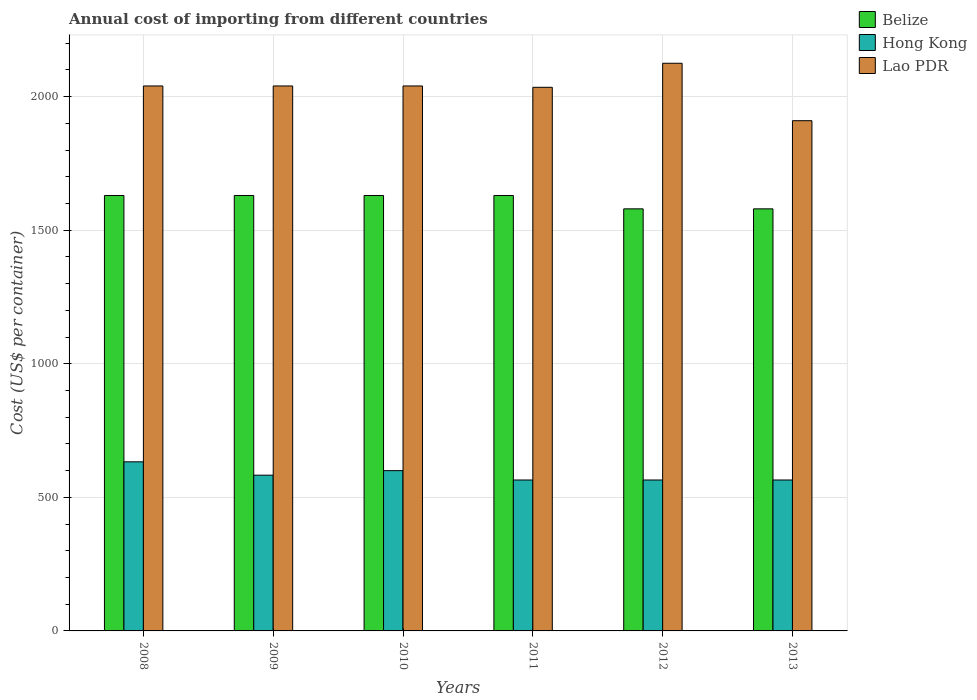How many groups of bars are there?
Offer a terse response. 6. How many bars are there on the 5th tick from the left?
Offer a very short reply. 3. In how many cases, is the number of bars for a given year not equal to the number of legend labels?
Provide a short and direct response. 0. What is the total annual cost of importing in Lao PDR in 2009?
Your answer should be compact. 2040. Across all years, what is the maximum total annual cost of importing in Hong Kong?
Provide a short and direct response. 633. Across all years, what is the minimum total annual cost of importing in Hong Kong?
Offer a very short reply. 565. What is the total total annual cost of importing in Hong Kong in the graph?
Your response must be concise. 3511. What is the difference between the total annual cost of importing in Belize in 2011 and that in 2013?
Keep it short and to the point. 50. What is the difference between the total annual cost of importing in Lao PDR in 2008 and the total annual cost of importing in Belize in 2013?
Offer a very short reply. 460. What is the average total annual cost of importing in Belize per year?
Give a very brief answer. 1613.33. In the year 2008, what is the difference between the total annual cost of importing in Belize and total annual cost of importing in Lao PDR?
Give a very brief answer. -410. What is the ratio of the total annual cost of importing in Lao PDR in 2009 to that in 2013?
Provide a short and direct response. 1.07. Is the total annual cost of importing in Hong Kong in 2009 less than that in 2012?
Keep it short and to the point. No. What is the difference between the highest and the lowest total annual cost of importing in Belize?
Make the answer very short. 50. What does the 1st bar from the left in 2009 represents?
Offer a terse response. Belize. What does the 1st bar from the right in 2012 represents?
Offer a terse response. Lao PDR. How many bars are there?
Your response must be concise. 18. Are all the bars in the graph horizontal?
Your response must be concise. No. How many years are there in the graph?
Offer a very short reply. 6. What is the difference between two consecutive major ticks on the Y-axis?
Your answer should be compact. 500. Does the graph contain any zero values?
Give a very brief answer. No. Where does the legend appear in the graph?
Provide a succinct answer. Top right. How many legend labels are there?
Offer a terse response. 3. What is the title of the graph?
Your answer should be very brief. Annual cost of importing from different countries. Does "El Salvador" appear as one of the legend labels in the graph?
Your answer should be compact. No. What is the label or title of the X-axis?
Provide a short and direct response. Years. What is the label or title of the Y-axis?
Provide a succinct answer. Cost (US$ per container). What is the Cost (US$ per container) in Belize in 2008?
Offer a very short reply. 1630. What is the Cost (US$ per container) in Hong Kong in 2008?
Give a very brief answer. 633. What is the Cost (US$ per container) in Lao PDR in 2008?
Your answer should be very brief. 2040. What is the Cost (US$ per container) in Belize in 2009?
Make the answer very short. 1630. What is the Cost (US$ per container) in Hong Kong in 2009?
Provide a short and direct response. 583. What is the Cost (US$ per container) in Lao PDR in 2009?
Offer a very short reply. 2040. What is the Cost (US$ per container) of Belize in 2010?
Offer a very short reply. 1630. What is the Cost (US$ per container) of Hong Kong in 2010?
Offer a very short reply. 600. What is the Cost (US$ per container) in Lao PDR in 2010?
Your response must be concise. 2040. What is the Cost (US$ per container) of Belize in 2011?
Your response must be concise. 1630. What is the Cost (US$ per container) of Hong Kong in 2011?
Provide a short and direct response. 565. What is the Cost (US$ per container) of Lao PDR in 2011?
Your answer should be compact. 2035. What is the Cost (US$ per container) of Belize in 2012?
Ensure brevity in your answer.  1580. What is the Cost (US$ per container) in Hong Kong in 2012?
Provide a succinct answer. 565. What is the Cost (US$ per container) of Lao PDR in 2012?
Your answer should be very brief. 2125. What is the Cost (US$ per container) of Belize in 2013?
Offer a terse response. 1580. What is the Cost (US$ per container) in Hong Kong in 2013?
Offer a terse response. 565. What is the Cost (US$ per container) in Lao PDR in 2013?
Keep it short and to the point. 1910. Across all years, what is the maximum Cost (US$ per container) in Belize?
Your answer should be compact. 1630. Across all years, what is the maximum Cost (US$ per container) of Hong Kong?
Your response must be concise. 633. Across all years, what is the maximum Cost (US$ per container) of Lao PDR?
Provide a short and direct response. 2125. Across all years, what is the minimum Cost (US$ per container) of Belize?
Offer a terse response. 1580. Across all years, what is the minimum Cost (US$ per container) in Hong Kong?
Your answer should be compact. 565. Across all years, what is the minimum Cost (US$ per container) of Lao PDR?
Offer a terse response. 1910. What is the total Cost (US$ per container) of Belize in the graph?
Give a very brief answer. 9680. What is the total Cost (US$ per container) of Hong Kong in the graph?
Offer a very short reply. 3511. What is the total Cost (US$ per container) in Lao PDR in the graph?
Offer a very short reply. 1.22e+04. What is the difference between the Cost (US$ per container) in Hong Kong in 2008 and that in 2009?
Offer a very short reply. 50. What is the difference between the Cost (US$ per container) of Lao PDR in 2008 and that in 2009?
Make the answer very short. 0. What is the difference between the Cost (US$ per container) of Belize in 2008 and that in 2010?
Your answer should be compact. 0. What is the difference between the Cost (US$ per container) in Hong Kong in 2008 and that in 2010?
Your answer should be compact. 33. What is the difference between the Cost (US$ per container) of Lao PDR in 2008 and that in 2010?
Make the answer very short. 0. What is the difference between the Cost (US$ per container) in Belize in 2008 and that in 2011?
Ensure brevity in your answer.  0. What is the difference between the Cost (US$ per container) in Hong Kong in 2008 and that in 2011?
Provide a short and direct response. 68. What is the difference between the Cost (US$ per container) of Lao PDR in 2008 and that in 2011?
Make the answer very short. 5. What is the difference between the Cost (US$ per container) in Hong Kong in 2008 and that in 2012?
Provide a succinct answer. 68. What is the difference between the Cost (US$ per container) in Lao PDR in 2008 and that in 2012?
Offer a very short reply. -85. What is the difference between the Cost (US$ per container) in Belize in 2008 and that in 2013?
Your response must be concise. 50. What is the difference between the Cost (US$ per container) in Hong Kong in 2008 and that in 2013?
Your answer should be very brief. 68. What is the difference between the Cost (US$ per container) of Lao PDR in 2008 and that in 2013?
Your answer should be very brief. 130. What is the difference between the Cost (US$ per container) of Belize in 2009 and that in 2010?
Offer a very short reply. 0. What is the difference between the Cost (US$ per container) of Lao PDR in 2009 and that in 2010?
Make the answer very short. 0. What is the difference between the Cost (US$ per container) in Belize in 2009 and that in 2012?
Keep it short and to the point. 50. What is the difference between the Cost (US$ per container) in Hong Kong in 2009 and that in 2012?
Offer a terse response. 18. What is the difference between the Cost (US$ per container) in Lao PDR in 2009 and that in 2012?
Offer a very short reply. -85. What is the difference between the Cost (US$ per container) of Hong Kong in 2009 and that in 2013?
Your answer should be compact. 18. What is the difference between the Cost (US$ per container) of Lao PDR in 2009 and that in 2013?
Your response must be concise. 130. What is the difference between the Cost (US$ per container) in Lao PDR in 2010 and that in 2011?
Your response must be concise. 5. What is the difference between the Cost (US$ per container) in Hong Kong in 2010 and that in 2012?
Ensure brevity in your answer.  35. What is the difference between the Cost (US$ per container) in Lao PDR in 2010 and that in 2012?
Make the answer very short. -85. What is the difference between the Cost (US$ per container) of Belize in 2010 and that in 2013?
Make the answer very short. 50. What is the difference between the Cost (US$ per container) of Hong Kong in 2010 and that in 2013?
Make the answer very short. 35. What is the difference between the Cost (US$ per container) of Lao PDR in 2010 and that in 2013?
Your response must be concise. 130. What is the difference between the Cost (US$ per container) of Lao PDR in 2011 and that in 2012?
Offer a terse response. -90. What is the difference between the Cost (US$ per container) in Belize in 2011 and that in 2013?
Your response must be concise. 50. What is the difference between the Cost (US$ per container) of Lao PDR in 2011 and that in 2013?
Keep it short and to the point. 125. What is the difference between the Cost (US$ per container) of Belize in 2012 and that in 2013?
Provide a short and direct response. 0. What is the difference between the Cost (US$ per container) of Lao PDR in 2012 and that in 2013?
Your response must be concise. 215. What is the difference between the Cost (US$ per container) in Belize in 2008 and the Cost (US$ per container) in Hong Kong in 2009?
Make the answer very short. 1047. What is the difference between the Cost (US$ per container) of Belize in 2008 and the Cost (US$ per container) of Lao PDR in 2009?
Give a very brief answer. -410. What is the difference between the Cost (US$ per container) of Hong Kong in 2008 and the Cost (US$ per container) of Lao PDR in 2009?
Make the answer very short. -1407. What is the difference between the Cost (US$ per container) of Belize in 2008 and the Cost (US$ per container) of Hong Kong in 2010?
Your response must be concise. 1030. What is the difference between the Cost (US$ per container) in Belize in 2008 and the Cost (US$ per container) in Lao PDR in 2010?
Keep it short and to the point. -410. What is the difference between the Cost (US$ per container) in Hong Kong in 2008 and the Cost (US$ per container) in Lao PDR in 2010?
Give a very brief answer. -1407. What is the difference between the Cost (US$ per container) of Belize in 2008 and the Cost (US$ per container) of Hong Kong in 2011?
Offer a very short reply. 1065. What is the difference between the Cost (US$ per container) in Belize in 2008 and the Cost (US$ per container) in Lao PDR in 2011?
Keep it short and to the point. -405. What is the difference between the Cost (US$ per container) of Hong Kong in 2008 and the Cost (US$ per container) of Lao PDR in 2011?
Provide a succinct answer. -1402. What is the difference between the Cost (US$ per container) in Belize in 2008 and the Cost (US$ per container) in Hong Kong in 2012?
Offer a very short reply. 1065. What is the difference between the Cost (US$ per container) in Belize in 2008 and the Cost (US$ per container) in Lao PDR in 2012?
Your answer should be compact. -495. What is the difference between the Cost (US$ per container) in Hong Kong in 2008 and the Cost (US$ per container) in Lao PDR in 2012?
Keep it short and to the point. -1492. What is the difference between the Cost (US$ per container) of Belize in 2008 and the Cost (US$ per container) of Hong Kong in 2013?
Your answer should be compact. 1065. What is the difference between the Cost (US$ per container) of Belize in 2008 and the Cost (US$ per container) of Lao PDR in 2013?
Your answer should be compact. -280. What is the difference between the Cost (US$ per container) in Hong Kong in 2008 and the Cost (US$ per container) in Lao PDR in 2013?
Give a very brief answer. -1277. What is the difference between the Cost (US$ per container) of Belize in 2009 and the Cost (US$ per container) of Hong Kong in 2010?
Your response must be concise. 1030. What is the difference between the Cost (US$ per container) of Belize in 2009 and the Cost (US$ per container) of Lao PDR in 2010?
Provide a succinct answer. -410. What is the difference between the Cost (US$ per container) of Hong Kong in 2009 and the Cost (US$ per container) of Lao PDR in 2010?
Offer a very short reply. -1457. What is the difference between the Cost (US$ per container) in Belize in 2009 and the Cost (US$ per container) in Hong Kong in 2011?
Your answer should be very brief. 1065. What is the difference between the Cost (US$ per container) in Belize in 2009 and the Cost (US$ per container) in Lao PDR in 2011?
Offer a very short reply. -405. What is the difference between the Cost (US$ per container) in Hong Kong in 2009 and the Cost (US$ per container) in Lao PDR in 2011?
Give a very brief answer. -1452. What is the difference between the Cost (US$ per container) in Belize in 2009 and the Cost (US$ per container) in Hong Kong in 2012?
Offer a very short reply. 1065. What is the difference between the Cost (US$ per container) of Belize in 2009 and the Cost (US$ per container) of Lao PDR in 2012?
Provide a succinct answer. -495. What is the difference between the Cost (US$ per container) of Hong Kong in 2009 and the Cost (US$ per container) of Lao PDR in 2012?
Your response must be concise. -1542. What is the difference between the Cost (US$ per container) in Belize in 2009 and the Cost (US$ per container) in Hong Kong in 2013?
Your answer should be very brief. 1065. What is the difference between the Cost (US$ per container) of Belize in 2009 and the Cost (US$ per container) of Lao PDR in 2013?
Give a very brief answer. -280. What is the difference between the Cost (US$ per container) of Hong Kong in 2009 and the Cost (US$ per container) of Lao PDR in 2013?
Your answer should be very brief. -1327. What is the difference between the Cost (US$ per container) in Belize in 2010 and the Cost (US$ per container) in Hong Kong in 2011?
Your answer should be very brief. 1065. What is the difference between the Cost (US$ per container) in Belize in 2010 and the Cost (US$ per container) in Lao PDR in 2011?
Give a very brief answer. -405. What is the difference between the Cost (US$ per container) of Hong Kong in 2010 and the Cost (US$ per container) of Lao PDR in 2011?
Your response must be concise. -1435. What is the difference between the Cost (US$ per container) of Belize in 2010 and the Cost (US$ per container) of Hong Kong in 2012?
Offer a very short reply. 1065. What is the difference between the Cost (US$ per container) of Belize in 2010 and the Cost (US$ per container) of Lao PDR in 2012?
Offer a terse response. -495. What is the difference between the Cost (US$ per container) in Hong Kong in 2010 and the Cost (US$ per container) in Lao PDR in 2012?
Give a very brief answer. -1525. What is the difference between the Cost (US$ per container) of Belize in 2010 and the Cost (US$ per container) of Hong Kong in 2013?
Give a very brief answer. 1065. What is the difference between the Cost (US$ per container) in Belize in 2010 and the Cost (US$ per container) in Lao PDR in 2013?
Ensure brevity in your answer.  -280. What is the difference between the Cost (US$ per container) in Hong Kong in 2010 and the Cost (US$ per container) in Lao PDR in 2013?
Provide a short and direct response. -1310. What is the difference between the Cost (US$ per container) in Belize in 2011 and the Cost (US$ per container) in Hong Kong in 2012?
Ensure brevity in your answer.  1065. What is the difference between the Cost (US$ per container) of Belize in 2011 and the Cost (US$ per container) of Lao PDR in 2012?
Give a very brief answer. -495. What is the difference between the Cost (US$ per container) of Hong Kong in 2011 and the Cost (US$ per container) of Lao PDR in 2012?
Provide a short and direct response. -1560. What is the difference between the Cost (US$ per container) in Belize in 2011 and the Cost (US$ per container) in Hong Kong in 2013?
Offer a very short reply. 1065. What is the difference between the Cost (US$ per container) of Belize in 2011 and the Cost (US$ per container) of Lao PDR in 2013?
Offer a terse response. -280. What is the difference between the Cost (US$ per container) in Hong Kong in 2011 and the Cost (US$ per container) in Lao PDR in 2013?
Your response must be concise. -1345. What is the difference between the Cost (US$ per container) of Belize in 2012 and the Cost (US$ per container) of Hong Kong in 2013?
Give a very brief answer. 1015. What is the difference between the Cost (US$ per container) of Belize in 2012 and the Cost (US$ per container) of Lao PDR in 2013?
Provide a short and direct response. -330. What is the difference between the Cost (US$ per container) in Hong Kong in 2012 and the Cost (US$ per container) in Lao PDR in 2013?
Your response must be concise. -1345. What is the average Cost (US$ per container) of Belize per year?
Your answer should be very brief. 1613.33. What is the average Cost (US$ per container) in Hong Kong per year?
Offer a very short reply. 585.17. What is the average Cost (US$ per container) of Lao PDR per year?
Offer a very short reply. 2031.67. In the year 2008, what is the difference between the Cost (US$ per container) in Belize and Cost (US$ per container) in Hong Kong?
Offer a terse response. 997. In the year 2008, what is the difference between the Cost (US$ per container) of Belize and Cost (US$ per container) of Lao PDR?
Your response must be concise. -410. In the year 2008, what is the difference between the Cost (US$ per container) of Hong Kong and Cost (US$ per container) of Lao PDR?
Provide a short and direct response. -1407. In the year 2009, what is the difference between the Cost (US$ per container) in Belize and Cost (US$ per container) in Hong Kong?
Your response must be concise. 1047. In the year 2009, what is the difference between the Cost (US$ per container) of Belize and Cost (US$ per container) of Lao PDR?
Your answer should be compact. -410. In the year 2009, what is the difference between the Cost (US$ per container) of Hong Kong and Cost (US$ per container) of Lao PDR?
Offer a very short reply. -1457. In the year 2010, what is the difference between the Cost (US$ per container) of Belize and Cost (US$ per container) of Hong Kong?
Ensure brevity in your answer.  1030. In the year 2010, what is the difference between the Cost (US$ per container) of Belize and Cost (US$ per container) of Lao PDR?
Offer a terse response. -410. In the year 2010, what is the difference between the Cost (US$ per container) of Hong Kong and Cost (US$ per container) of Lao PDR?
Offer a terse response. -1440. In the year 2011, what is the difference between the Cost (US$ per container) of Belize and Cost (US$ per container) of Hong Kong?
Your response must be concise. 1065. In the year 2011, what is the difference between the Cost (US$ per container) in Belize and Cost (US$ per container) in Lao PDR?
Ensure brevity in your answer.  -405. In the year 2011, what is the difference between the Cost (US$ per container) in Hong Kong and Cost (US$ per container) in Lao PDR?
Provide a short and direct response. -1470. In the year 2012, what is the difference between the Cost (US$ per container) of Belize and Cost (US$ per container) of Hong Kong?
Offer a very short reply. 1015. In the year 2012, what is the difference between the Cost (US$ per container) in Belize and Cost (US$ per container) in Lao PDR?
Make the answer very short. -545. In the year 2012, what is the difference between the Cost (US$ per container) of Hong Kong and Cost (US$ per container) of Lao PDR?
Your answer should be compact. -1560. In the year 2013, what is the difference between the Cost (US$ per container) in Belize and Cost (US$ per container) in Hong Kong?
Make the answer very short. 1015. In the year 2013, what is the difference between the Cost (US$ per container) of Belize and Cost (US$ per container) of Lao PDR?
Provide a short and direct response. -330. In the year 2013, what is the difference between the Cost (US$ per container) in Hong Kong and Cost (US$ per container) in Lao PDR?
Your answer should be compact. -1345. What is the ratio of the Cost (US$ per container) in Belize in 2008 to that in 2009?
Provide a short and direct response. 1. What is the ratio of the Cost (US$ per container) of Hong Kong in 2008 to that in 2009?
Ensure brevity in your answer.  1.09. What is the ratio of the Cost (US$ per container) of Lao PDR in 2008 to that in 2009?
Ensure brevity in your answer.  1. What is the ratio of the Cost (US$ per container) of Hong Kong in 2008 to that in 2010?
Make the answer very short. 1.05. What is the ratio of the Cost (US$ per container) of Hong Kong in 2008 to that in 2011?
Give a very brief answer. 1.12. What is the ratio of the Cost (US$ per container) of Lao PDR in 2008 to that in 2011?
Your response must be concise. 1. What is the ratio of the Cost (US$ per container) in Belize in 2008 to that in 2012?
Provide a succinct answer. 1.03. What is the ratio of the Cost (US$ per container) of Hong Kong in 2008 to that in 2012?
Your answer should be compact. 1.12. What is the ratio of the Cost (US$ per container) of Lao PDR in 2008 to that in 2012?
Your response must be concise. 0.96. What is the ratio of the Cost (US$ per container) in Belize in 2008 to that in 2013?
Keep it short and to the point. 1.03. What is the ratio of the Cost (US$ per container) in Hong Kong in 2008 to that in 2013?
Give a very brief answer. 1.12. What is the ratio of the Cost (US$ per container) in Lao PDR in 2008 to that in 2013?
Keep it short and to the point. 1.07. What is the ratio of the Cost (US$ per container) of Hong Kong in 2009 to that in 2010?
Give a very brief answer. 0.97. What is the ratio of the Cost (US$ per container) of Belize in 2009 to that in 2011?
Your answer should be compact. 1. What is the ratio of the Cost (US$ per container) in Hong Kong in 2009 to that in 2011?
Ensure brevity in your answer.  1.03. What is the ratio of the Cost (US$ per container) in Lao PDR in 2009 to that in 2011?
Provide a short and direct response. 1. What is the ratio of the Cost (US$ per container) in Belize in 2009 to that in 2012?
Your answer should be very brief. 1.03. What is the ratio of the Cost (US$ per container) in Hong Kong in 2009 to that in 2012?
Provide a short and direct response. 1.03. What is the ratio of the Cost (US$ per container) of Lao PDR in 2009 to that in 2012?
Give a very brief answer. 0.96. What is the ratio of the Cost (US$ per container) of Belize in 2009 to that in 2013?
Your answer should be very brief. 1.03. What is the ratio of the Cost (US$ per container) in Hong Kong in 2009 to that in 2013?
Provide a succinct answer. 1.03. What is the ratio of the Cost (US$ per container) in Lao PDR in 2009 to that in 2013?
Give a very brief answer. 1.07. What is the ratio of the Cost (US$ per container) in Hong Kong in 2010 to that in 2011?
Provide a short and direct response. 1.06. What is the ratio of the Cost (US$ per container) of Lao PDR in 2010 to that in 2011?
Keep it short and to the point. 1. What is the ratio of the Cost (US$ per container) in Belize in 2010 to that in 2012?
Keep it short and to the point. 1.03. What is the ratio of the Cost (US$ per container) of Hong Kong in 2010 to that in 2012?
Make the answer very short. 1.06. What is the ratio of the Cost (US$ per container) in Belize in 2010 to that in 2013?
Offer a terse response. 1.03. What is the ratio of the Cost (US$ per container) of Hong Kong in 2010 to that in 2013?
Provide a succinct answer. 1.06. What is the ratio of the Cost (US$ per container) in Lao PDR in 2010 to that in 2013?
Provide a short and direct response. 1.07. What is the ratio of the Cost (US$ per container) of Belize in 2011 to that in 2012?
Provide a succinct answer. 1.03. What is the ratio of the Cost (US$ per container) of Hong Kong in 2011 to that in 2012?
Your answer should be very brief. 1. What is the ratio of the Cost (US$ per container) of Lao PDR in 2011 to that in 2012?
Ensure brevity in your answer.  0.96. What is the ratio of the Cost (US$ per container) of Belize in 2011 to that in 2013?
Keep it short and to the point. 1.03. What is the ratio of the Cost (US$ per container) in Hong Kong in 2011 to that in 2013?
Offer a very short reply. 1. What is the ratio of the Cost (US$ per container) of Lao PDR in 2011 to that in 2013?
Your answer should be very brief. 1.07. What is the ratio of the Cost (US$ per container) of Belize in 2012 to that in 2013?
Ensure brevity in your answer.  1. What is the ratio of the Cost (US$ per container) in Lao PDR in 2012 to that in 2013?
Offer a very short reply. 1.11. What is the difference between the highest and the lowest Cost (US$ per container) of Lao PDR?
Provide a succinct answer. 215. 